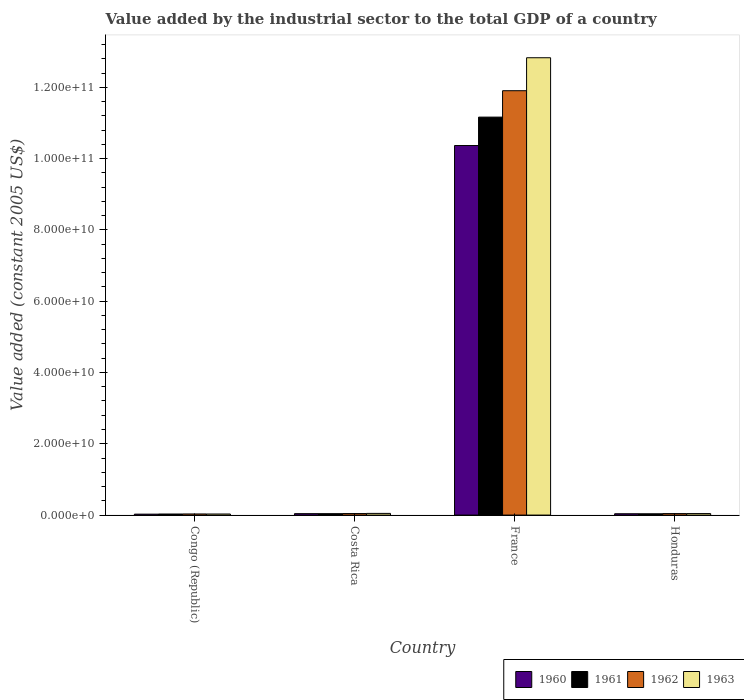How many groups of bars are there?
Make the answer very short. 4. Are the number of bars per tick equal to the number of legend labels?
Offer a very short reply. Yes. Are the number of bars on each tick of the X-axis equal?
Provide a succinct answer. Yes. How many bars are there on the 4th tick from the left?
Offer a very short reply. 4. How many bars are there on the 3rd tick from the right?
Provide a short and direct response. 4. What is the label of the 2nd group of bars from the left?
Offer a terse response. Costa Rica. In how many cases, is the number of bars for a given country not equal to the number of legend labels?
Offer a terse response. 0. What is the value added by the industrial sector in 1961 in Congo (Republic)?
Keep it short and to the point. 2.98e+08. Across all countries, what is the maximum value added by the industrial sector in 1962?
Your response must be concise. 1.19e+11. Across all countries, what is the minimum value added by the industrial sector in 1960?
Your answer should be very brief. 2.61e+08. In which country was the value added by the industrial sector in 1963 maximum?
Offer a very short reply. France. In which country was the value added by the industrial sector in 1961 minimum?
Your answer should be compact. Congo (Republic). What is the total value added by the industrial sector in 1962 in the graph?
Ensure brevity in your answer.  1.20e+11. What is the difference between the value added by the industrial sector in 1960 in Costa Rica and that in France?
Ensure brevity in your answer.  -1.03e+11. What is the difference between the value added by the industrial sector in 1961 in Honduras and the value added by the industrial sector in 1963 in France?
Make the answer very short. -1.28e+11. What is the average value added by the industrial sector in 1963 per country?
Make the answer very short. 3.24e+1. What is the difference between the value added by the industrial sector of/in 1962 and value added by the industrial sector of/in 1960 in France?
Provide a short and direct response. 1.54e+1. What is the ratio of the value added by the industrial sector in 1961 in Costa Rica to that in France?
Offer a terse response. 0. What is the difference between the highest and the second highest value added by the industrial sector in 1961?
Your response must be concise. -2.78e+07. What is the difference between the highest and the lowest value added by the industrial sector in 1963?
Keep it short and to the point. 1.28e+11. Is it the case that in every country, the sum of the value added by the industrial sector in 1960 and value added by the industrial sector in 1961 is greater than the sum of value added by the industrial sector in 1963 and value added by the industrial sector in 1962?
Provide a short and direct response. No. What does the 1st bar from the left in France represents?
Your answer should be very brief. 1960. What does the 1st bar from the right in Congo (Republic) represents?
Give a very brief answer. 1963. How many bars are there?
Provide a short and direct response. 16. Are the values on the major ticks of Y-axis written in scientific E-notation?
Ensure brevity in your answer.  Yes. Does the graph contain any zero values?
Make the answer very short. No. What is the title of the graph?
Your answer should be compact. Value added by the industrial sector to the total GDP of a country. What is the label or title of the Y-axis?
Give a very brief answer. Value added (constant 2005 US$). What is the Value added (constant 2005 US$) in 1960 in Congo (Republic)?
Provide a succinct answer. 2.61e+08. What is the Value added (constant 2005 US$) of 1961 in Congo (Republic)?
Give a very brief answer. 2.98e+08. What is the Value added (constant 2005 US$) of 1962 in Congo (Republic)?
Offer a very short reply. 3.12e+08. What is the Value added (constant 2005 US$) of 1963 in Congo (Republic)?
Provide a succinct answer. 3.00e+08. What is the Value added (constant 2005 US$) in 1960 in Costa Rica?
Provide a short and direct response. 3.98e+08. What is the Value added (constant 2005 US$) of 1961 in Costa Rica?
Provide a succinct answer. 3.94e+08. What is the Value added (constant 2005 US$) in 1962 in Costa Rica?
Provide a succinct answer. 4.27e+08. What is the Value added (constant 2005 US$) of 1963 in Costa Rica?
Make the answer very short. 4.68e+08. What is the Value added (constant 2005 US$) in 1960 in France?
Give a very brief answer. 1.04e+11. What is the Value added (constant 2005 US$) of 1961 in France?
Give a very brief answer. 1.12e+11. What is the Value added (constant 2005 US$) in 1962 in France?
Provide a short and direct response. 1.19e+11. What is the Value added (constant 2005 US$) in 1963 in France?
Offer a terse response. 1.28e+11. What is the Value added (constant 2005 US$) of 1960 in Honduras?
Your answer should be compact. 3.75e+08. What is the Value added (constant 2005 US$) in 1961 in Honduras?
Make the answer very short. 3.66e+08. What is the Value added (constant 2005 US$) in 1962 in Honduras?
Give a very brief answer. 4.16e+08. What is the Value added (constant 2005 US$) of 1963 in Honduras?
Offer a terse response. 4.23e+08. Across all countries, what is the maximum Value added (constant 2005 US$) in 1960?
Keep it short and to the point. 1.04e+11. Across all countries, what is the maximum Value added (constant 2005 US$) in 1961?
Your answer should be compact. 1.12e+11. Across all countries, what is the maximum Value added (constant 2005 US$) of 1962?
Offer a terse response. 1.19e+11. Across all countries, what is the maximum Value added (constant 2005 US$) of 1963?
Your answer should be very brief. 1.28e+11. Across all countries, what is the minimum Value added (constant 2005 US$) of 1960?
Offer a terse response. 2.61e+08. Across all countries, what is the minimum Value added (constant 2005 US$) of 1961?
Keep it short and to the point. 2.98e+08. Across all countries, what is the minimum Value added (constant 2005 US$) of 1962?
Keep it short and to the point. 3.12e+08. Across all countries, what is the minimum Value added (constant 2005 US$) in 1963?
Your answer should be very brief. 3.00e+08. What is the total Value added (constant 2005 US$) in 1960 in the graph?
Ensure brevity in your answer.  1.05e+11. What is the total Value added (constant 2005 US$) in 1961 in the graph?
Your response must be concise. 1.13e+11. What is the total Value added (constant 2005 US$) of 1962 in the graph?
Offer a terse response. 1.20e+11. What is the total Value added (constant 2005 US$) in 1963 in the graph?
Provide a short and direct response. 1.29e+11. What is the difference between the Value added (constant 2005 US$) of 1960 in Congo (Republic) and that in Costa Rica?
Provide a short and direct response. -1.36e+08. What is the difference between the Value added (constant 2005 US$) of 1961 in Congo (Republic) and that in Costa Rica?
Your answer should be very brief. -9.59e+07. What is the difference between the Value added (constant 2005 US$) in 1962 in Congo (Republic) and that in Costa Rica?
Your answer should be very brief. -1.14e+08. What is the difference between the Value added (constant 2005 US$) in 1963 in Congo (Republic) and that in Costa Rica?
Your answer should be very brief. -1.68e+08. What is the difference between the Value added (constant 2005 US$) of 1960 in Congo (Republic) and that in France?
Offer a very short reply. -1.03e+11. What is the difference between the Value added (constant 2005 US$) in 1961 in Congo (Republic) and that in France?
Offer a terse response. -1.11e+11. What is the difference between the Value added (constant 2005 US$) of 1962 in Congo (Republic) and that in France?
Give a very brief answer. -1.19e+11. What is the difference between the Value added (constant 2005 US$) in 1963 in Congo (Republic) and that in France?
Your answer should be compact. -1.28e+11. What is the difference between the Value added (constant 2005 US$) of 1960 in Congo (Republic) and that in Honduras?
Give a very brief answer. -1.14e+08. What is the difference between the Value added (constant 2005 US$) of 1961 in Congo (Republic) and that in Honduras?
Give a very brief answer. -6.81e+07. What is the difference between the Value added (constant 2005 US$) in 1962 in Congo (Republic) and that in Honduras?
Give a very brief answer. -1.03e+08. What is the difference between the Value added (constant 2005 US$) of 1963 in Congo (Republic) and that in Honduras?
Your answer should be very brief. -1.23e+08. What is the difference between the Value added (constant 2005 US$) in 1960 in Costa Rica and that in France?
Give a very brief answer. -1.03e+11. What is the difference between the Value added (constant 2005 US$) of 1961 in Costa Rica and that in France?
Make the answer very short. -1.11e+11. What is the difference between the Value added (constant 2005 US$) in 1962 in Costa Rica and that in France?
Your answer should be very brief. -1.19e+11. What is the difference between the Value added (constant 2005 US$) in 1963 in Costa Rica and that in France?
Provide a succinct answer. -1.28e+11. What is the difference between the Value added (constant 2005 US$) in 1960 in Costa Rica and that in Honduras?
Your answer should be very brief. 2.26e+07. What is the difference between the Value added (constant 2005 US$) of 1961 in Costa Rica and that in Honduras?
Offer a very short reply. 2.78e+07. What is the difference between the Value added (constant 2005 US$) in 1962 in Costa Rica and that in Honduras?
Your answer should be compact. 1.10e+07. What is the difference between the Value added (constant 2005 US$) in 1963 in Costa Rica and that in Honduras?
Your response must be concise. 4.49e+07. What is the difference between the Value added (constant 2005 US$) of 1960 in France and that in Honduras?
Provide a succinct answer. 1.03e+11. What is the difference between the Value added (constant 2005 US$) of 1961 in France and that in Honduras?
Ensure brevity in your answer.  1.11e+11. What is the difference between the Value added (constant 2005 US$) of 1962 in France and that in Honduras?
Your answer should be very brief. 1.19e+11. What is the difference between the Value added (constant 2005 US$) of 1963 in France and that in Honduras?
Provide a short and direct response. 1.28e+11. What is the difference between the Value added (constant 2005 US$) in 1960 in Congo (Republic) and the Value added (constant 2005 US$) in 1961 in Costa Rica?
Keep it short and to the point. -1.32e+08. What is the difference between the Value added (constant 2005 US$) of 1960 in Congo (Republic) and the Value added (constant 2005 US$) of 1962 in Costa Rica?
Provide a succinct answer. -1.65e+08. What is the difference between the Value added (constant 2005 US$) in 1960 in Congo (Republic) and the Value added (constant 2005 US$) in 1963 in Costa Rica?
Make the answer very short. -2.07e+08. What is the difference between the Value added (constant 2005 US$) in 1961 in Congo (Republic) and the Value added (constant 2005 US$) in 1962 in Costa Rica?
Offer a terse response. -1.29e+08. What is the difference between the Value added (constant 2005 US$) of 1961 in Congo (Republic) and the Value added (constant 2005 US$) of 1963 in Costa Rica?
Your answer should be very brief. -1.70e+08. What is the difference between the Value added (constant 2005 US$) of 1962 in Congo (Republic) and the Value added (constant 2005 US$) of 1963 in Costa Rica?
Your response must be concise. -1.56e+08. What is the difference between the Value added (constant 2005 US$) in 1960 in Congo (Republic) and the Value added (constant 2005 US$) in 1961 in France?
Offer a terse response. -1.11e+11. What is the difference between the Value added (constant 2005 US$) of 1960 in Congo (Republic) and the Value added (constant 2005 US$) of 1962 in France?
Your answer should be very brief. -1.19e+11. What is the difference between the Value added (constant 2005 US$) of 1960 in Congo (Republic) and the Value added (constant 2005 US$) of 1963 in France?
Offer a terse response. -1.28e+11. What is the difference between the Value added (constant 2005 US$) of 1961 in Congo (Republic) and the Value added (constant 2005 US$) of 1962 in France?
Your response must be concise. -1.19e+11. What is the difference between the Value added (constant 2005 US$) in 1961 in Congo (Republic) and the Value added (constant 2005 US$) in 1963 in France?
Provide a short and direct response. -1.28e+11. What is the difference between the Value added (constant 2005 US$) of 1962 in Congo (Republic) and the Value added (constant 2005 US$) of 1963 in France?
Offer a very short reply. -1.28e+11. What is the difference between the Value added (constant 2005 US$) of 1960 in Congo (Republic) and the Value added (constant 2005 US$) of 1961 in Honduras?
Your answer should be very brief. -1.04e+08. What is the difference between the Value added (constant 2005 US$) in 1960 in Congo (Republic) and the Value added (constant 2005 US$) in 1962 in Honduras?
Provide a short and direct response. -1.54e+08. What is the difference between the Value added (constant 2005 US$) of 1960 in Congo (Republic) and the Value added (constant 2005 US$) of 1963 in Honduras?
Your answer should be compact. -1.62e+08. What is the difference between the Value added (constant 2005 US$) in 1961 in Congo (Republic) and the Value added (constant 2005 US$) in 1962 in Honduras?
Your answer should be compact. -1.18e+08. What is the difference between the Value added (constant 2005 US$) of 1961 in Congo (Republic) and the Value added (constant 2005 US$) of 1963 in Honduras?
Keep it short and to the point. -1.25e+08. What is the difference between the Value added (constant 2005 US$) in 1962 in Congo (Republic) and the Value added (constant 2005 US$) in 1963 in Honduras?
Keep it short and to the point. -1.11e+08. What is the difference between the Value added (constant 2005 US$) in 1960 in Costa Rica and the Value added (constant 2005 US$) in 1961 in France?
Make the answer very short. -1.11e+11. What is the difference between the Value added (constant 2005 US$) of 1960 in Costa Rica and the Value added (constant 2005 US$) of 1962 in France?
Give a very brief answer. -1.19e+11. What is the difference between the Value added (constant 2005 US$) of 1960 in Costa Rica and the Value added (constant 2005 US$) of 1963 in France?
Your answer should be compact. -1.28e+11. What is the difference between the Value added (constant 2005 US$) in 1961 in Costa Rica and the Value added (constant 2005 US$) in 1962 in France?
Provide a short and direct response. -1.19e+11. What is the difference between the Value added (constant 2005 US$) in 1961 in Costa Rica and the Value added (constant 2005 US$) in 1963 in France?
Ensure brevity in your answer.  -1.28e+11. What is the difference between the Value added (constant 2005 US$) of 1962 in Costa Rica and the Value added (constant 2005 US$) of 1963 in France?
Make the answer very short. -1.28e+11. What is the difference between the Value added (constant 2005 US$) in 1960 in Costa Rica and the Value added (constant 2005 US$) in 1961 in Honduras?
Offer a very short reply. 3.20e+07. What is the difference between the Value added (constant 2005 US$) in 1960 in Costa Rica and the Value added (constant 2005 US$) in 1962 in Honduras?
Keep it short and to the point. -1.81e+07. What is the difference between the Value added (constant 2005 US$) of 1960 in Costa Rica and the Value added (constant 2005 US$) of 1963 in Honduras?
Your answer should be compact. -2.52e+07. What is the difference between the Value added (constant 2005 US$) of 1961 in Costa Rica and the Value added (constant 2005 US$) of 1962 in Honduras?
Your answer should be very brief. -2.22e+07. What is the difference between the Value added (constant 2005 US$) in 1961 in Costa Rica and the Value added (constant 2005 US$) in 1963 in Honduras?
Offer a terse response. -2.94e+07. What is the difference between the Value added (constant 2005 US$) of 1962 in Costa Rica and the Value added (constant 2005 US$) of 1963 in Honduras?
Provide a short and direct response. 3.81e+06. What is the difference between the Value added (constant 2005 US$) of 1960 in France and the Value added (constant 2005 US$) of 1961 in Honduras?
Your answer should be very brief. 1.03e+11. What is the difference between the Value added (constant 2005 US$) of 1960 in France and the Value added (constant 2005 US$) of 1962 in Honduras?
Give a very brief answer. 1.03e+11. What is the difference between the Value added (constant 2005 US$) of 1960 in France and the Value added (constant 2005 US$) of 1963 in Honduras?
Your answer should be compact. 1.03e+11. What is the difference between the Value added (constant 2005 US$) in 1961 in France and the Value added (constant 2005 US$) in 1962 in Honduras?
Offer a terse response. 1.11e+11. What is the difference between the Value added (constant 2005 US$) in 1961 in France and the Value added (constant 2005 US$) in 1963 in Honduras?
Your answer should be very brief. 1.11e+11. What is the difference between the Value added (constant 2005 US$) of 1962 in France and the Value added (constant 2005 US$) of 1963 in Honduras?
Your response must be concise. 1.19e+11. What is the average Value added (constant 2005 US$) of 1960 per country?
Provide a succinct answer. 2.62e+1. What is the average Value added (constant 2005 US$) of 1961 per country?
Offer a very short reply. 2.82e+1. What is the average Value added (constant 2005 US$) in 1962 per country?
Offer a terse response. 3.00e+1. What is the average Value added (constant 2005 US$) in 1963 per country?
Keep it short and to the point. 3.24e+1. What is the difference between the Value added (constant 2005 US$) of 1960 and Value added (constant 2005 US$) of 1961 in Congo (Republic)?
Keep it short and to the point. -3.63e+07. What is the difference between the Value added (constant 2005 US$) of 1960 and Value added (constant 2005 US$) of 1962 in Congo (Republic)?
Your response must be concise. -5.10e+07. What is the difference between the Value added (constant 2005 US$) of 1960 and Value added (constant 2005 US$) of 1963 in Congo (Republic)?
Your answer should be very brief. -3.84e+07. What is the difference between the Value added (constant 2005 US$) in 1961 and Value added (constant 2005 US$) in 1962 in Congo (Republic)?
Make the answer very short. -1.47e+07. What is the difference between the Value added (constant 2005 US$) of 1961 and Value added (constant 2005 US$) of 1963 in Congo (Republic)?
Your answer should be compact. -2.10e+06. What is the difference between the Value added (constant 2005 US$) in 1962 and Value added (constant 2005 US$) in 1963 in Congo (Republic)?
Provide a succinct answer. 1.26e+07. What is the difference between the Value added (constant 2005 US$) in 1960 and Value added (constant 2005 US$) in 1961 in Costa Rica?
Provide a succinct answer. 4.19e+06. What is the difference between the Value added (constant 2005 US$) of 1960 and Value added (constant 2005 US$) of 1962 in Costa Rica?
Provide a short and direct response. -2.91e+07. What is the difference between the Value added (constant 2005 US$) of 1960 and Value added (constant 2005 US$) of 1963 in Costa Rica?
Provide a short and direct response. -7.01e+07. What is the difference between the Value added (constant 2005 US$) in 1961 and Value added (constant 2005 US$) in 1962 in Costa Rica?
Your answer should be very brief. -3.32e+07. What is the difference between the Value added (constant 2005 US$) in 1961 and Value added (constant 2005 US$) in 1963 in Costa Rica?
Make the answer very short. -7.43e+07. What is the difference between the Value added (constant 2005 US$) of 1962 and Value added (constant 2005 US$) of 1963 in Costa Rica?
Your answer should be compact. -4.11e+07. What is the difference between the Value added (constant 2005 US$) of 1960 and Value added (constant 2005 US$) of 1961 in France?
Keep it short and to the point. -7.97e+09. What is the difference between the Value added (constant 2005 US$) in 1960 and Value added (constant 2005 US$) in 1962 in France?
Offer a very short reply. -1.54e+1. What is the difference between the Value added (constant 2005 US$) in 1960 and Value added (constant 2005 US$) in 1963 in France?
Ensure brevity in your answer.  -2.46e+1. What is the difference between the Value added (constant 2005 US$) of 1961 and Value added (constant 2005 US$) of 1962 in France?
Provide a short and direct response. -7.41e+09. What is the difference between the Value added (constant 2005 US$) in 1961 and Value added (constant 2005 US$) in 1963 in France?
Provide a short and direct response. -1.67e+1. What is the difference between the Value added (constant 2005 US$) in 1962 and Value added (constant 2005 US$) in 1963 in France?
Make the answer very short. -9.25e+09. What is the difference between the Value added (constant 2005 US$) in 1960 and Value added (constant 2005 US$) in 1961 in Honduras?
Provide a succinct answer. 9.37e+06. What is the difference between the Value added (constant 2005 US$) in 1960 and Value added (constant 2005 US$) in 1962 in Honduras?
Provide a succinct answer. -4.07e+07. What is the difference between the Value added (constant 2005 US$) in 1960 and Value added (constant 2005 US$) in 1963 in Honduras?
Your response must be concise. -4.79e+07. What is the difference between the Value added (constant 2005 US$) in 1961 and Value added (constant 2005 US$) in 1962 in Honduras?
Provide a succinct answer. -5.00e+07. What is the difference between the Value added (constant 2005 US$) in 1961 and Value added (constant 2005 US$) in 1963 in Honduras?
Make the answer very short. -5.72e+07. What is the difference between the Value added (constant 2005 US$) in 1962 and Value added (constant 2005 US$) in 1963 in Honduras?
Make the answer very short. -7.19e+06. What is the ratio of the Value added (constant 2005 US$) of 1960 in Congo (Republic) to that in Costa Rica?
Your answer should be compact. 0.66. What is the ratio of the Value added (constant 2005 US$) of 1961 in Congo (Republic) to that in Costa Rica?
Your response must be concise. 0.76. What is the ratio of the Value added (constant 2005 US$) of 1962 in Congo (Republic) to that in Costa Rica?
Keep it short and to the point. 0.73. What is the ratio of the Value added (constant 2005 US$) of 1963 in Congo (Republic) to that in Costa Rica?
Give a very brief answer. 0.64. What is the ratio of the Value added (constant 2005 US$) of 1960 in Congo (Republic) to that in France?
Your answer should be compact. 0. What is the ratio of the Value added (constant 2005 US$) of 1961 in Congo (Republic) to that in France?
Your answer should be compact. 0. What is the ratio of the Value added (constant 2005 US$) of 1962 in Congo (Republic) to that in France?
Offer a terse response. 0. What is the ratio of the Value added (constant 2005 US$) of 1963 in Congo (Republic) to that in France?
Ensure brevity in your answer.  0. What is the ratio of the Value added (constant 2005 US$) of 1960 in Congo (Republic) to that in Honduras?
Your answer should be compact. 0.7. What is the ratio of the Value added (constant 2005 US$) of 1961 in Congo (Republic) to that in Honduras?
Offer a terse response. 0.81. What is the ratio of the Value added (constant 2005 US$) in 1962 in Congo (Republic) to that in Honduras?
Provide a succinct answer. 0.75. What is the ratio of the Value added (constant 2005 US$) of 1963 in Congo (Republic) to that in Honduras?
Your answer should be very brief. 0.71. What is the ratio of the Value added (constant 2005 US$) in 1960 in Costa Rica to that in France?
Your response must be concise. 0. What is the ratio of the Value added (constant 2005 US$) in 1961 in Costa Rica to that in France?
Your answer should be very brief. 0. What is the ratio of the Value added (constant 2005 US$) in 1962 in Costa Rica to that in France?
Ensure brevity in your answer.  0. What is the ratio of the Value added (constant 2005 US$) in 1963 in Costa Rica to that in France?
Provide a succinct answer. 0. What is the ratio of the Value added (constant 2005 US$) of 1960 in Costa Rica to that in Honduras?
Provide a short and direct response. 1.06. What is the ratio of the Value added (constant 2005 US$) of 1961 in Costa Rica to that in Honduras?
Provide a succinct answer. 1.08. What is the ratio of the Value added (constant 2005 US$) in 1962 in Costa Rica to that in Honduras?
Ensure brevity in your answer.  1.03. What is the ratio of the Value added (constant 2005 US$) of 1963 in Costa Rica to that in Honduras?
Give a very brief answer. 1.11. What is the ratio of the Value added (constant 2005 US$) in 1960 in France to that in Honduras?
Your answer should be very brief. 276.31. What is the ratio of the Value added (constant 2005 US$) in 1961 in France to that in Honduras?
Make the answer very short. 305.16. What is the ratio of the Value added (constant 2005 US$) of 1962 in France to that in Honduras?
Make the answer very short. 286.26. What is the ratio of the Value added (constant 2005 US$) in 1963 in France to that in Honduras?
Give a very brief answer. 303.25. What is the difference between the highest and the second highest Value added (constant 2005 US$) of 1960?
Make the answer very short. 1.03e+11. What is the difference between the highest and the second highest Value added (constant 2005 US$) in 1961?
Provide a succinct answer. 1.11e+11. What is the difference between the highest and the second highest Value added (constant 2005 US$) in 1962?
Your answer should be compact. 1.19e+11. What is the difference between the highest and the second highest Value added (constant 2005 US$) in 1963?
Provide a short and direct response. 1.28e+11. What is the difference between the highest and the lowest Value added (constant 2005 US$) in 1960?
Make the answer very short. 1.03e+11. What is the difference between the highest and the lowest Value added (constant 2005 US$) in 1961?
Keep it short and to the point. 1.11e+11. What is the difference between the highest and the lowest Value added (constant 2005 US$) of 1962?
Your answer should be very brief. 1.19e+11. What is the difference between the highest and the lowest Value added (constant 2005 US$) of 1963?
Your response must be concise. 1.28e+11. 